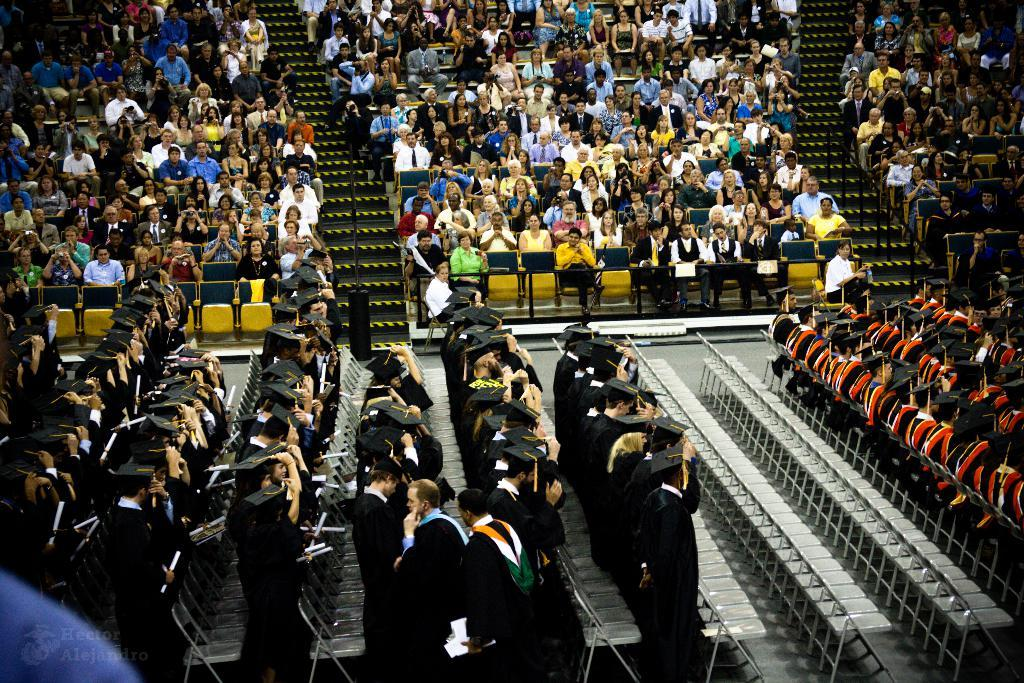What event is taking place in the image? The image is taken during convocation time. How are the people arranged in the image? There are many people sitting on chairs in the image. Is there any text or symbol in the image? Yes, there is a logo with text in the bottom left corner of the image. Can you see any matches or drawers in the image? No, there are no matches or drawers present in the image. Is there a fireman attending to the event in the image? No, there is no fireman present in the image. 